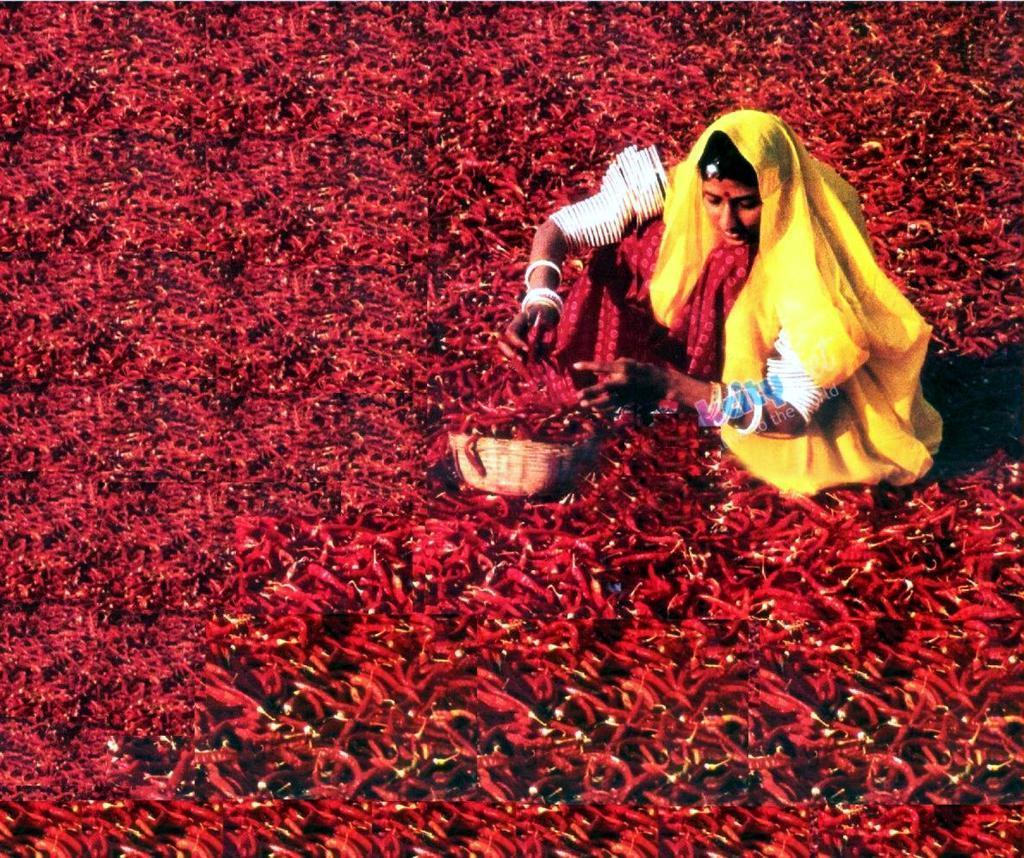How would you summarize this image in a sentence or two? In this picture there is a lady who is sitting on the right side of the image and there are chillies around the area of the image. 